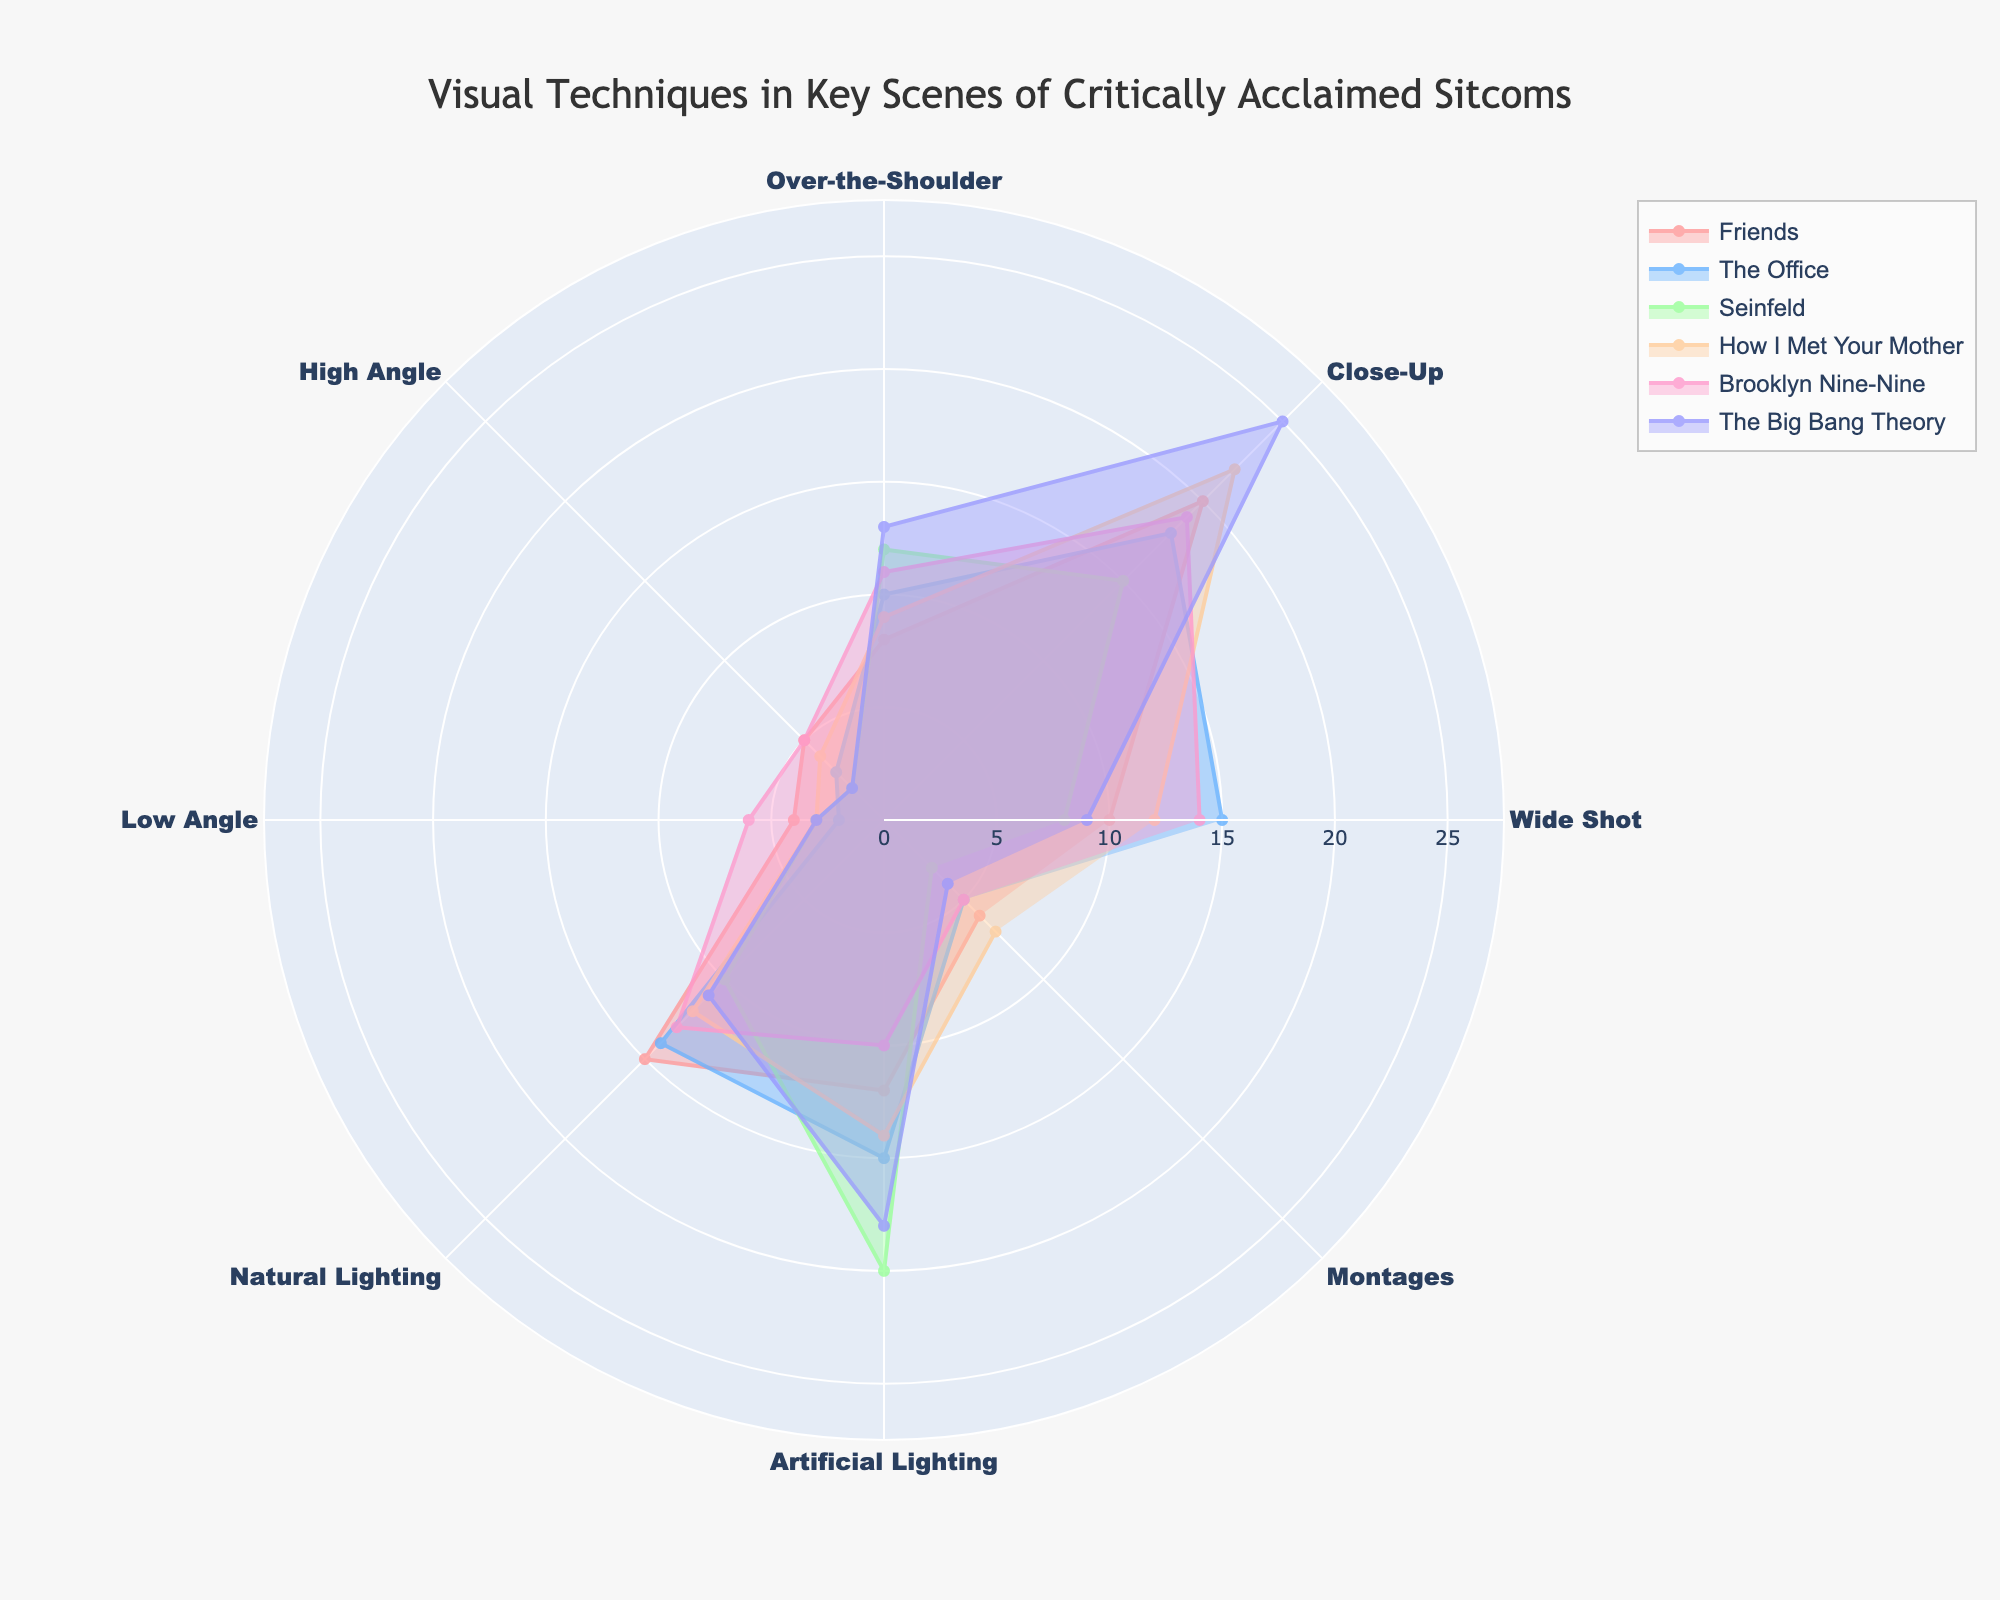How many visual techniques are analyzed in the chart? The chart analyzes eight visual techniques. This can be easily verified by counting the categories on the radial axis of the polar area chart.
Answer: 8 Which sitcom uses the most wide shots? To find this, look at the radial value for wide shots across all the sitcoms. "The Office" has the highest value of 15 for wide shots.
Answer: The Office What is the total number of close-up shots used across all sitcoms? Add the values of close-up shots for all sitcoms: 20 (Friends) + 18 (The Office) + 15 (Seinfeld) + 22 (How I Met Your Mother) + 19 (Brooklyn Nine-Nine) + 25 (The Big Bang Theory) = 119
Answer: 119 Which sitcom has the least variation in the use of camera angles (wide shot, close-up, over-the-shoulder, high angle, low angle)? Calculate the range (difference between max and min) for camera angles for each sitcom and compare. Friends: 20-4=16, The Office: 18-2=16, Seinfeld:15-2=13, How I Met Your Mother: 22-3=19, Brooklyn Nine-Nine: 19-5=14, The Big Bang Theory: 25-2=23. Seinfeld has the lowest range of 13.
Answer: Seinfeld In which category does "The Big Bang Theory" have the highest value among all categories? Inspect the values for each category for "The Big Bang Theory" and identify the maximum one. The highest value for The Big Bang Theory is 25 for close-up shots.
Answer: Close-Up Which sitcom uses more artificial lighting than natural lighting? Compare the values of artificial lighting and natural lighting for each sitcom. "The Office" (15 vs. 14), "Seinfeld" (20 vs. 10), "The Big Bang Theory" (18 vs. 11) uses more artificial lighting than natural lighting.
Answer: The Office, Seinfeld, The Big Bang Theory How many sitcoms use high angle shots less frequently than low angle shots? Compare the values of high angle and low angle shots for each sitcom. "The Office" (3 vs. 2) and "Brooklyn Nine-Nine" (5 vs. 6) have fewer high angle shots than low angle shots.
Answer: 2 Which category has the most uniform distribution across all sitcoms? Inspect the values for each category and calculate the range (difference between maximum and minimum values). The category with the lowest range will be the most uniform. Close-Up: 25-15=10, Wideshot: 15-8=7, Over-the-Shoulder: 13-8=5, High Angle: 5-2=3, Low Angle: 6-2=4, Natural Lighting: 15-10=5, Artificial Lighting: 20-10=10, Montages: 7-3=4. High angle has the most uniform distribution with a range of 3.
Answer: High Angle Which sitcom uses montages the most? Compare the values for the "Montages" category across sitcoms. "How I Met Your Mother" has a value of 7, which is the highest for montages.
Answer: How I Met Your Mother 